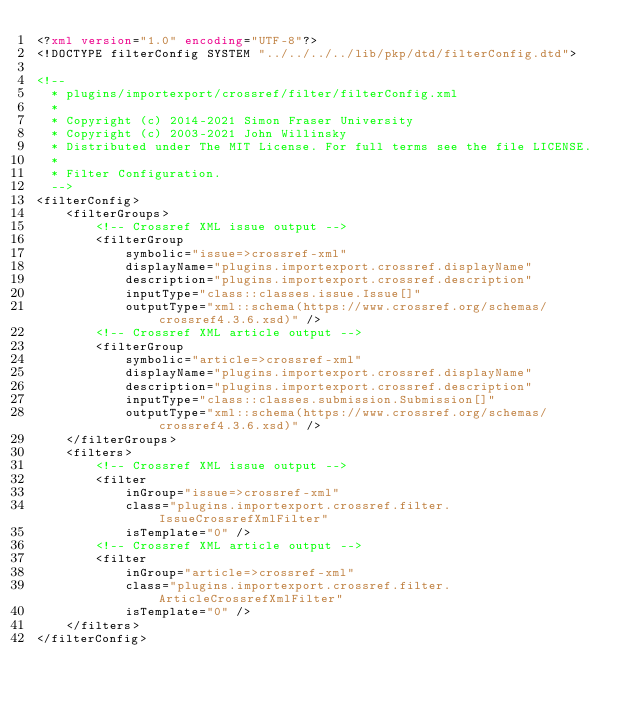Convert code to text. <code><loc_0><loc_0><loc_500><loc_500><_XML_><?xml version="1.0" encoding="UTF-8"?>
<!DOCTYPE filterConfig SYSTEM "../../../../lib/pkp/dtd/filterConfig.dtd">

<!--
  * plugins/importexport/crossref/filter/filterConfig.xml
  *
  * Copyright (c) 2014-2021 Simon Fraser University
  * Copyright (c) 2003-2021 John Willinsky
  * Distributed under The MIT License. For full terms see the file LICENSE.
  *
  * Filter Configuration.
  -->
<filterConfig>
	<filterGroups>
		<!-- Crossref XML issue output -->
		<filterGroup
			symbolic="issue=>crossref-xml"
			displayName="plugins.importexport.crossref.displayName"
			description="plugins.importexport.crossref.description"
			inputType="class::classes.issue.Issue[]"
			outputType="xml::schema(https://www.crossref.org/schemas/crossref4.3.6.xsd)" />
		<!-- Crossref XML article output -->
		<filterGroup
			symbolic="article=>crossref-xml"
			displayName="plugins.importexport.crossref.displayName"
			description="plugins.importexport.crossref.description"
			inputType="class::classes.submission.Submission[]"
			outputType="xml::schema(https://www.crossref.org/schemas/crossref4.3.6.xsd)" />
	</filterGroups>
	<filters>
		<!-- Crossref XML issue output -->
		<filter
			inGroup="issue=>crossref-xml"
			class="plugins.importexport.crossref.filter.IssueCrossrefXmlFilter"
			isTemplate="0" />
		<!-- Crossref XML article output -->
		<filter
			inGroup="article=>crossref-xml"
			class="plugins.importexport.crossref.filter.ArticleCrossrefXmlFilter"
			isTemplate="0" />
	</filters>
</filterConfig>
</code> 